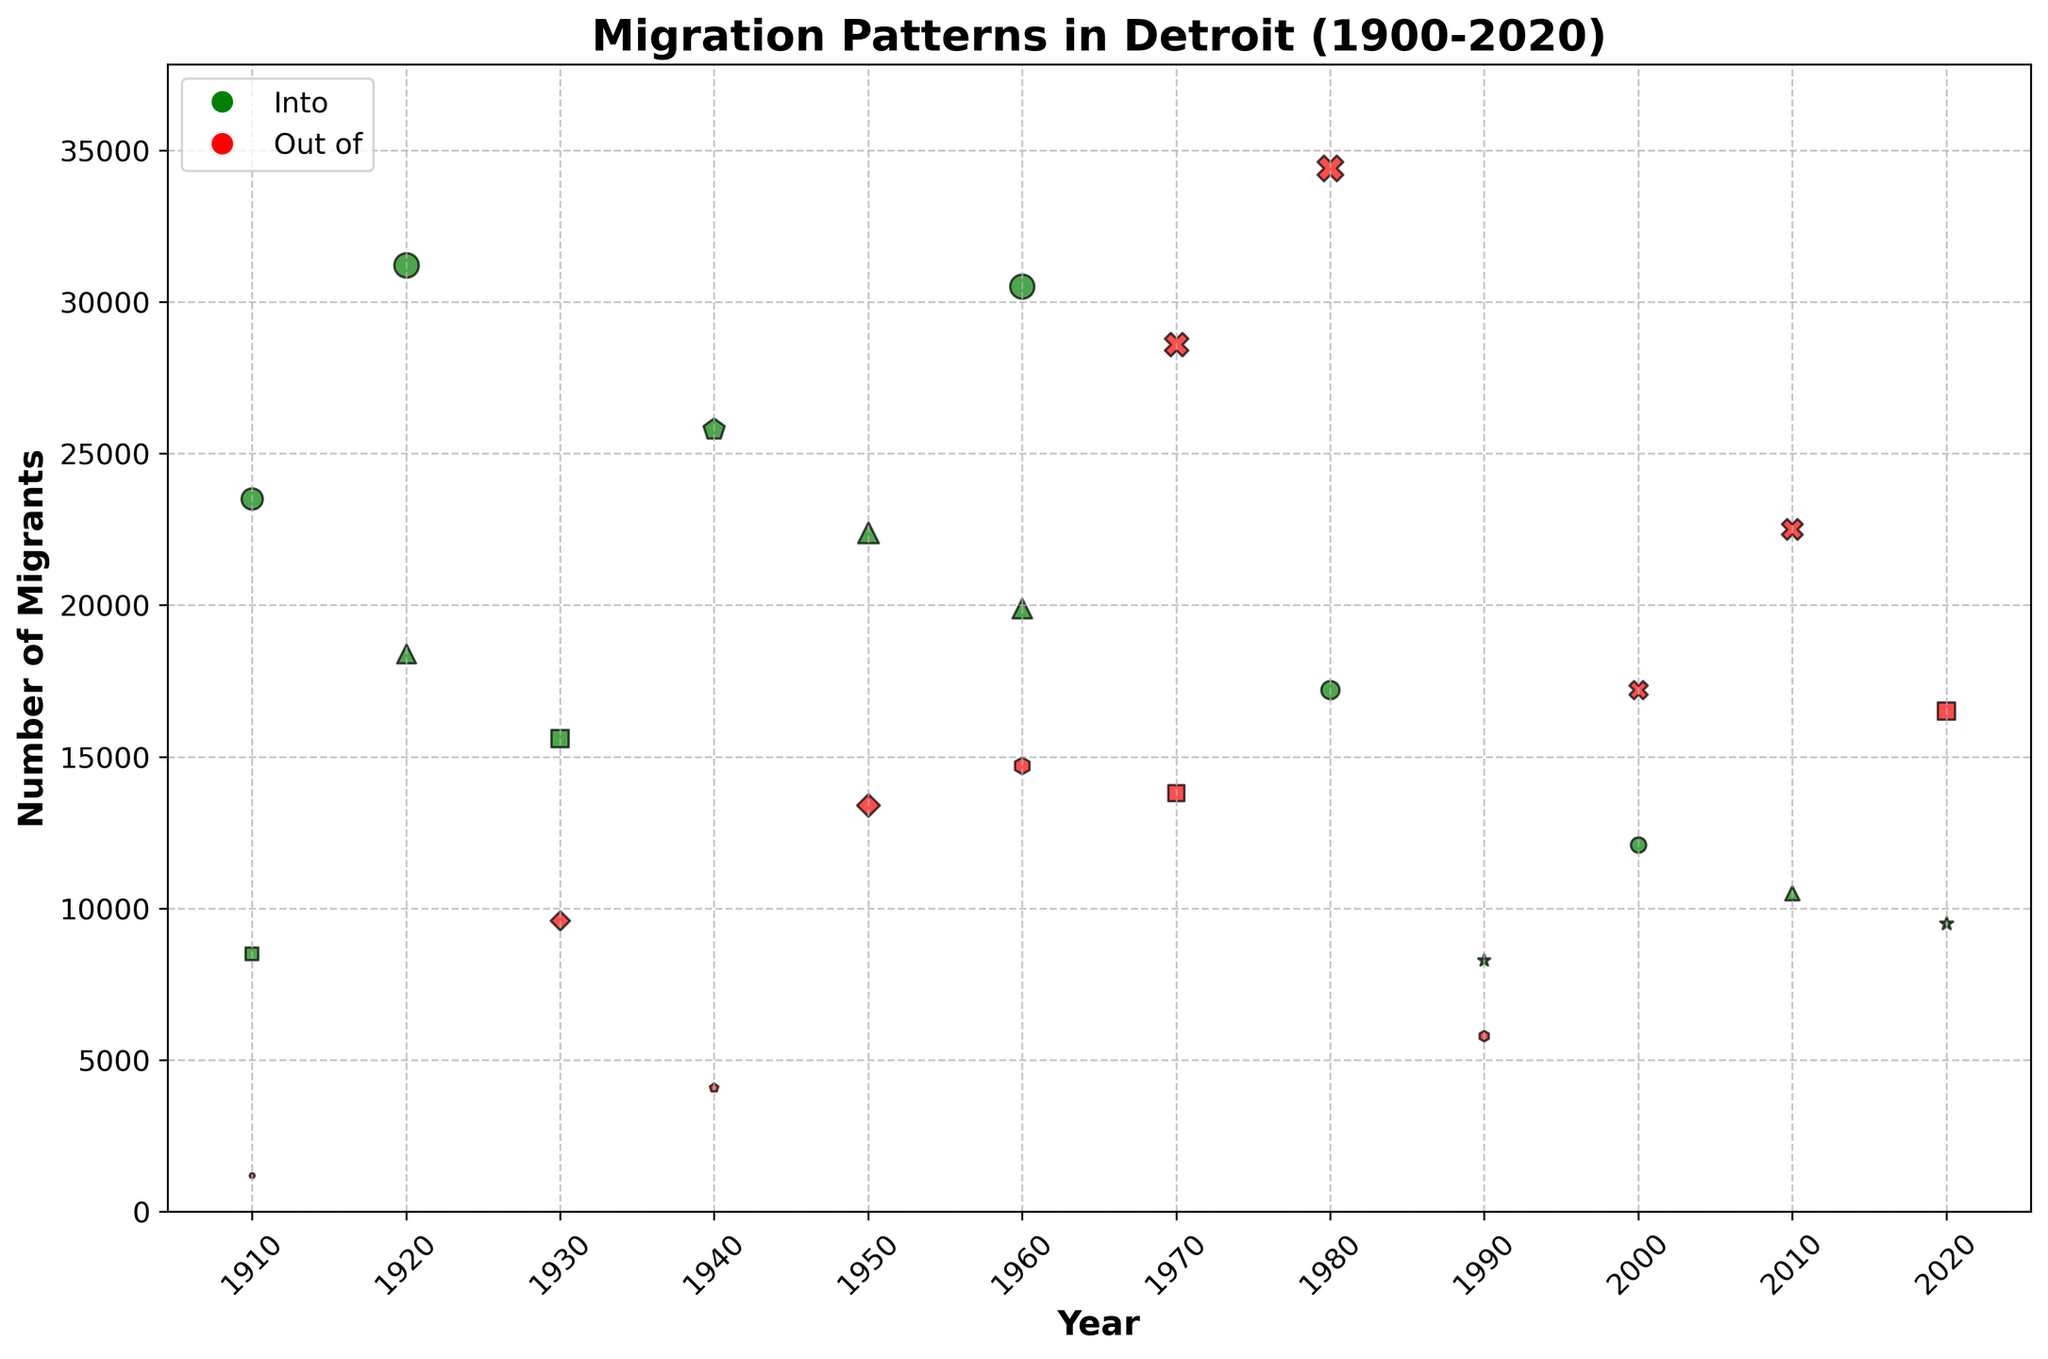what is the title of the figure? The title is located at the top of the figure and helps to summarize the content of the visualization. This information is often plainly visible.
Answer: Migration Patterns in Detroit (1900-2020) How many directions of migration are represented in the figure? By examining the color legend or the distinct colors within the figure, we can see there are two directions: "Into" and "Out of."
Answer: 2 Which migration type has the largest bubble in 1940? To answer this, look at the bubbles in 1940 and compare their sizes. The largest bubble is for Northern States under the "Into" category.
Answer: Into Northern States What is the average number of migrants "Out of" Detroit in 1960 and 1970? First, find the number of migrants migrating out in 1960 and 1970, which are 14700 and 28600. Then calculate the average as (14700 + 28600) / 2.
Answer: 21650 What migration destination had the largest increase in the number of "Into" migrants from 1910 to 1920? To determine the largest increase, compare the "Into" migration numbers of each destination from 1910 and 1920. South States increased from 23500 to 31200.
Answer: South States Which year had the highest number of migrants moving into Detroit from European Countries? Identify the number of European migrants for each year and find the maximum value. The year is 1950 with 22400 migrants.
Answer: 1950 In which year did Detroit see the largest number of migrants moving "Out of" from Western States? Check the migration numbers for "Out of" Western States across the years and find the highest number: 1980 with 34400 migrants.
Answer: 1980 How many total migration events are shown for the year 2000? Count each separate bubble represented for the year 2000 which include both "Into" and "Out of" migrations: Western States and South States.
Answer: 2 Compare the migration patterns into Detroit from European Countries and Asian Countries in 2020. Which was higher? Compare the bubble sizes or values for European Countries and Asian Countries in 2020. Asian Countries had fewer migrants (9500) than European Countries (21400).
Answer: European Countries Which decade experienced the highest total number of "Out of" migration events from any specific region? Summarize the number of "Out of" migrations for each decade, then find the decade with the highest total. The 1970s had a notable high number from Western States at 28600.
Answer: 1970s 